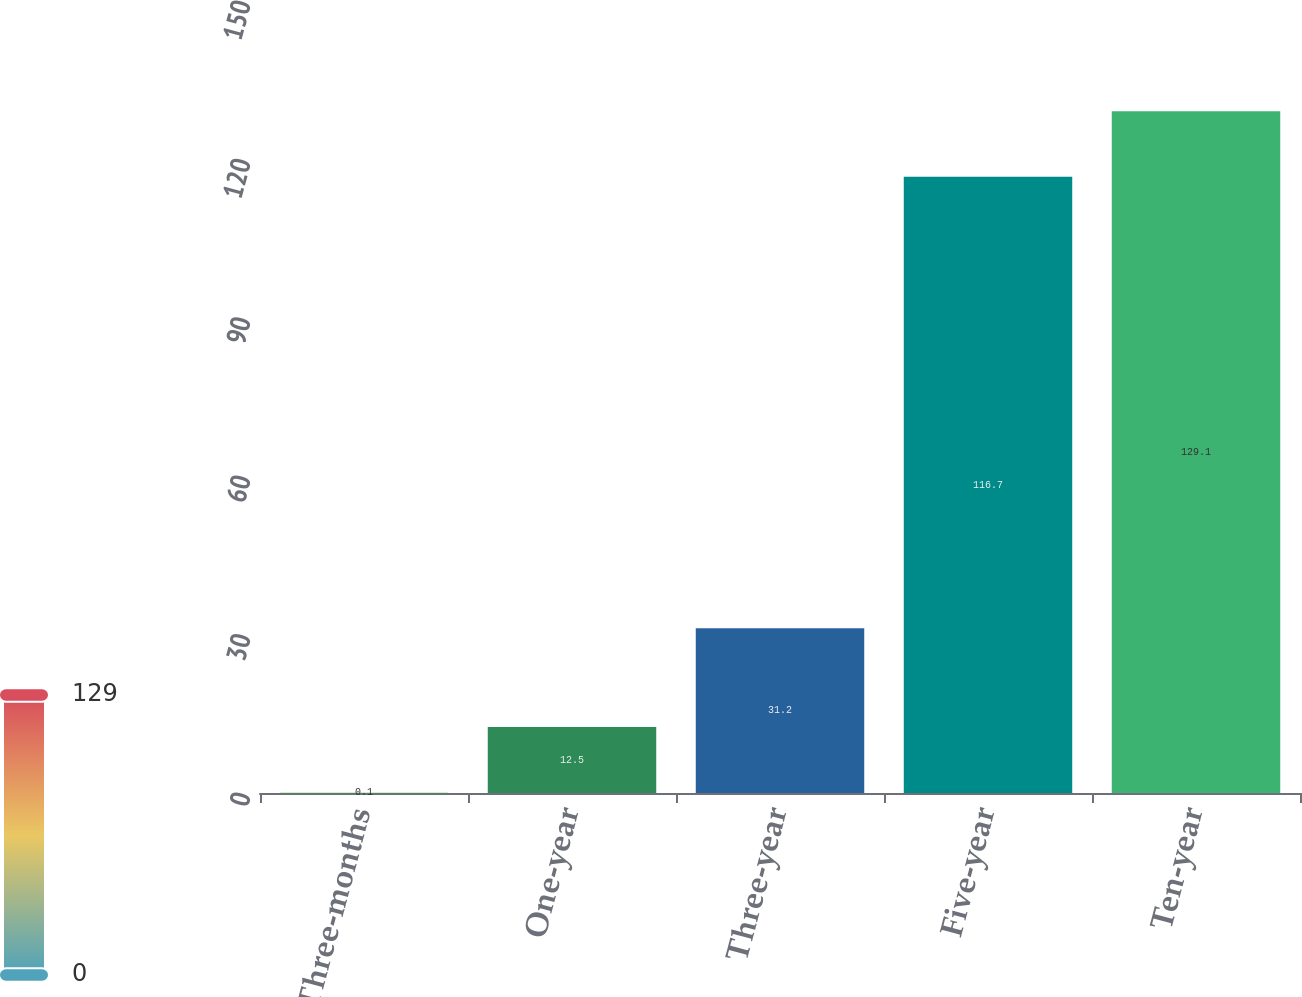<chart> <loc_0><loc_0><loc_500><loc_500><bar_chart><fcel>Three-months<fcel>One-year<fcel>Three-year<fcel>Five-year<fcel>Ten-year<nl><fcel>0.1<fcel>12.5<fcel>31.2<fcel>116.7<fcel>129.1<nl></chart> 